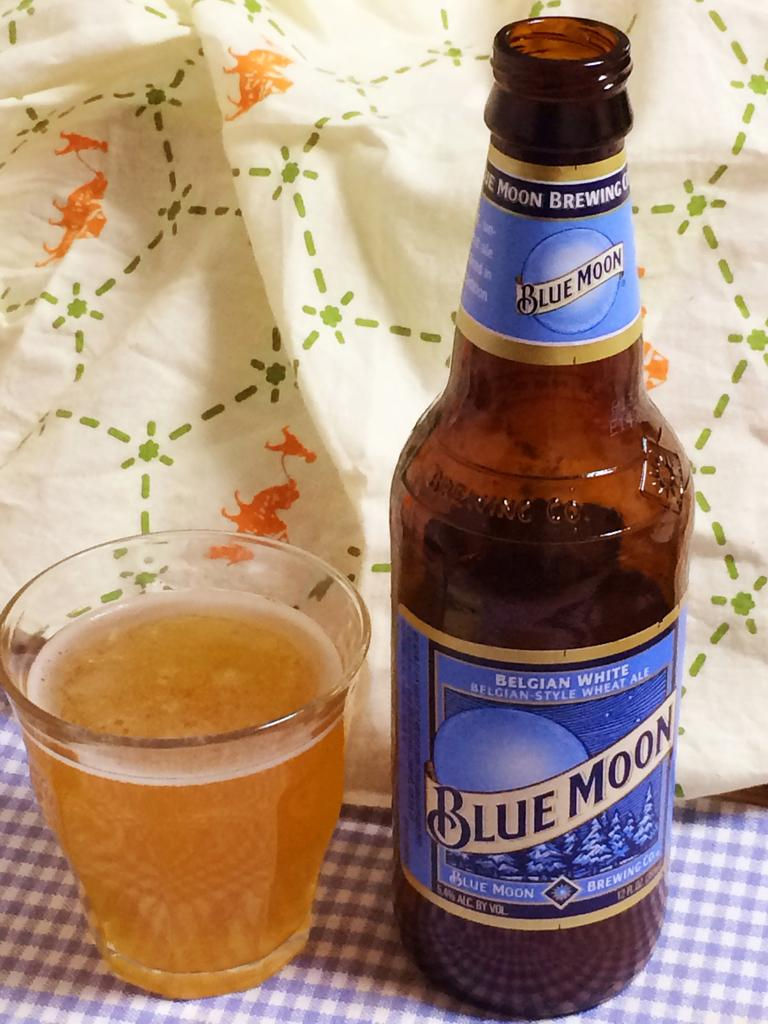<image>
Provide a brief description of the given image. A bottle of Blue Moon has been poured into a glass a on blue checkered cloth 